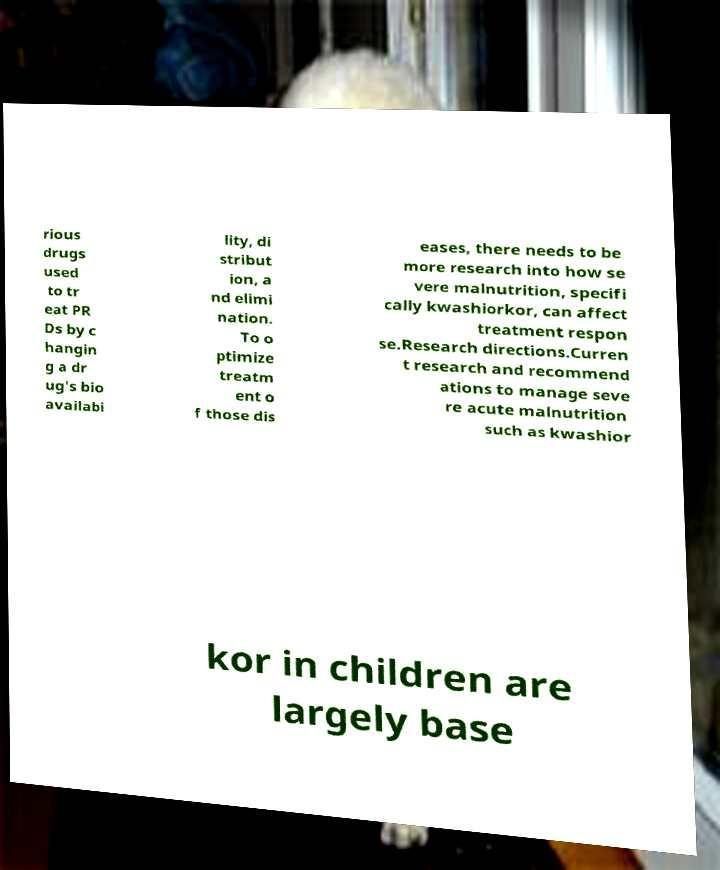Could you extract and type out the text from this image? rious drugs used to tr eat PR Ds by c hangin g a dr ug's bio availabi lity, di stribut ion, a nd elimi nation. To o ptimize treatm ent o f those dis eases, there needs to be more research into how se vere malnutrition, specifi cally kwashiorkor, can affect treatment respon se.Research directions.Curren t research and recommend ations to manage seve re acute malnutrition such as kwashior kor in children are largely base 